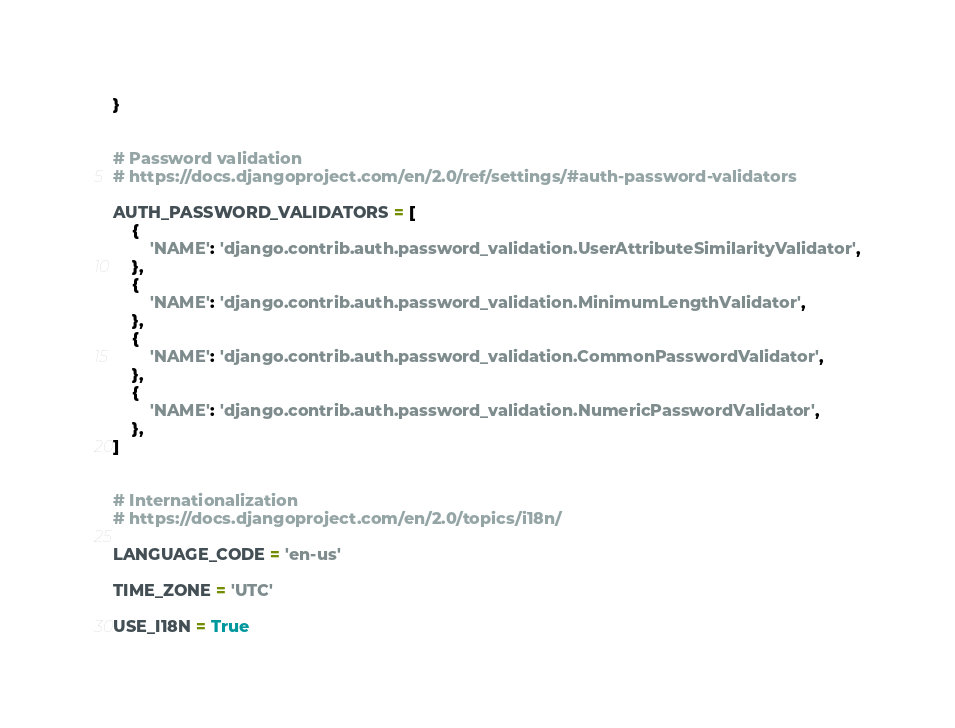Convert code to text. <code><loc_0><loc_0><loc_500><loc_500><_Python_>}


# Password validation
# https://docs.djangoproject.com/en/2.0/ref/settings/#auth-password-validators

AUTH_PASSWORD_VALIDATORS = [
    {
        'NAME': 'django.contrib.auth.password_validation.UserAttributeSimilarityValidator',
    },
    {
        'NAME': 'django.contrib.auth.password_validation.MinimumLengthValidator',
    },
    {
        'NAME': 'django.contrib.auth.password_validation.CommonPasswordValidator',
    },
    {
        'NAME': 'django.contrib.auth.password_validation.NumericPasswordValidator',
    },
]


# Internationalization
# https://docs.djangoproject.com/en/2.0/topics/i18n/

LANGUAGE_CODE = 'en-us'

TIME_ZONE = 'UTC'

USE_I18N = True
</code> 